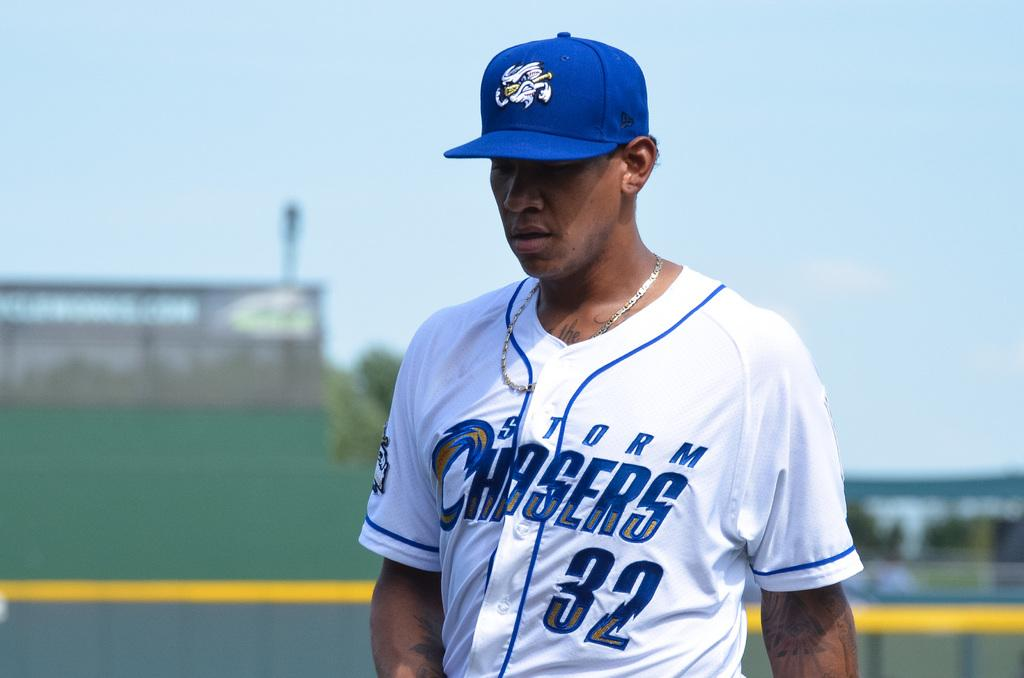<image>
Summarize the visual content of the image. A baseball player is wearing a Storm Chasers 32 jersey. 